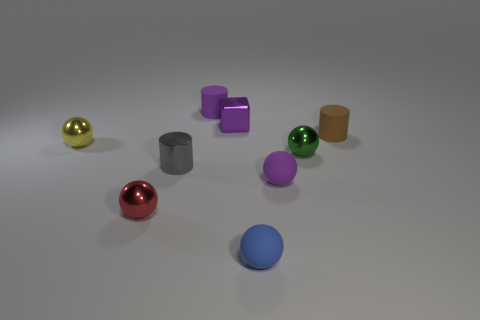Add 1 green metallic things. How many objects exist? 10 Subtract all brown rubber cylinders. How many cylinders are left? 2 Add 8 red things. How many red things exist? 9 Subtract all brown cylinders. How many cylinders are left? 2 Subtract 1 gray cylinders. How many objects are left? 8 Subtract all spheres. How many objects are left? 4 Subtract 1 cylinders. How many cylinders are left? 2 Subtract all red balls. Subtract all gray cylinders. How many balls are left? 4 Subtract all cyan cubes. How many blue spheres are left? 1 Subtract all big yellow cylinders. Subtract all tiny purple cubes. How many objects are left? 8 